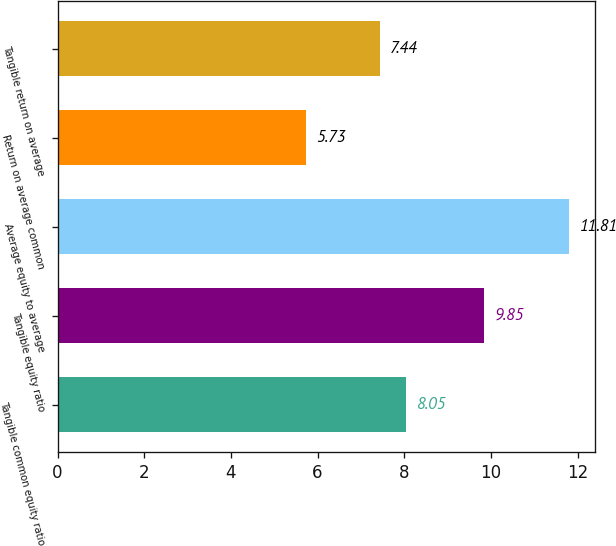Convert chart to OTSL. <chart><loc_0><loc_0><loc_500><loc_500><bar_chart><fcel>Tangible common equity ratio<fcel>Tangible equity ratio<fcel>Average equity to average<fcel>Return on average common<fcel>Tangible return on average<nl><fcel>8.05<fcel>9.85<fcel>11.81<fcel>5.73<fcel>7.44<nl></chart> 